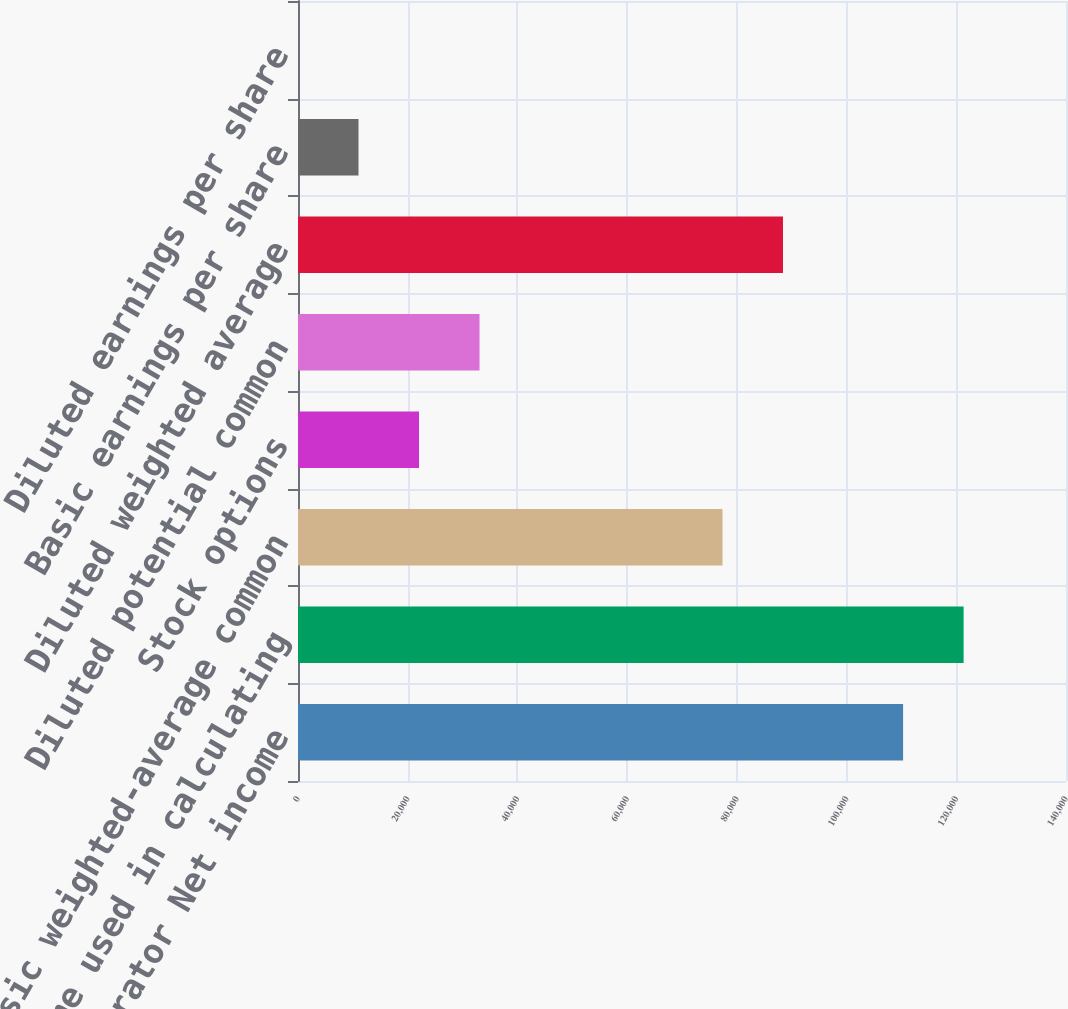Convert chart. <chart><loc_0><loc_0><loc_500><loc_500><bar_chart><fcel>Numerator Net income<fcel>Net income used in calculating<fcel>Basic weighted-average common<fcel>Stock options<fcel>Diluted potential common<fcel>Diluted weighted average<fcel>Basic earnings per share<fcel>Diluted earnings per share<nl><fcel>110303<fcel>121333<fcel>77378<fcel>22061.7<fcel>33091.9<fcel>88408.2<fcel>11031.6<fcel>1.4<nl></chart> 